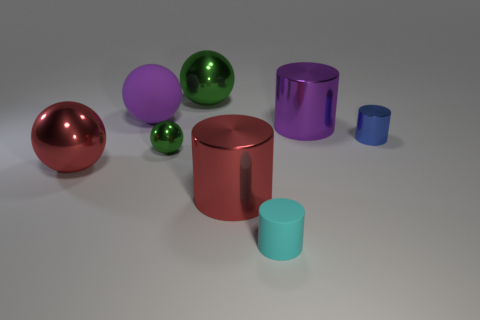Are there any other things that are the same size as the red ball?
Your answer should be compact. Yes. How many green things are either large shiny cylinders or shiny spheres?
Keep it short and to the point. 2. What number of cyan rubber cylinders have the same size as the blue shiny cylinder?
Provide a succinct answer. 1. What color is the large object that is both right of the purple rubber thing and in front of the blue thing?
Provide a short and direct response. Red. Is the number of big red balls right of the rubber ball greater than the number of big rubber spheres?
Make the answer very short. No. Is there a big green rubber object?
Offer a terse response. No. Is the large rubber ball the same color as the small matte cylinder?
Keep it short and to the point. No. What number of big things are either purple shiny cylinders or spheres?
Your answer should be compact. 4. Is there anything else that has the same color as the matte cylinder?
Your answer should be very brief. No. What is the shape of the blue object that is made of the same material as the red sphere?
Make the answer very short. Cylinder. 